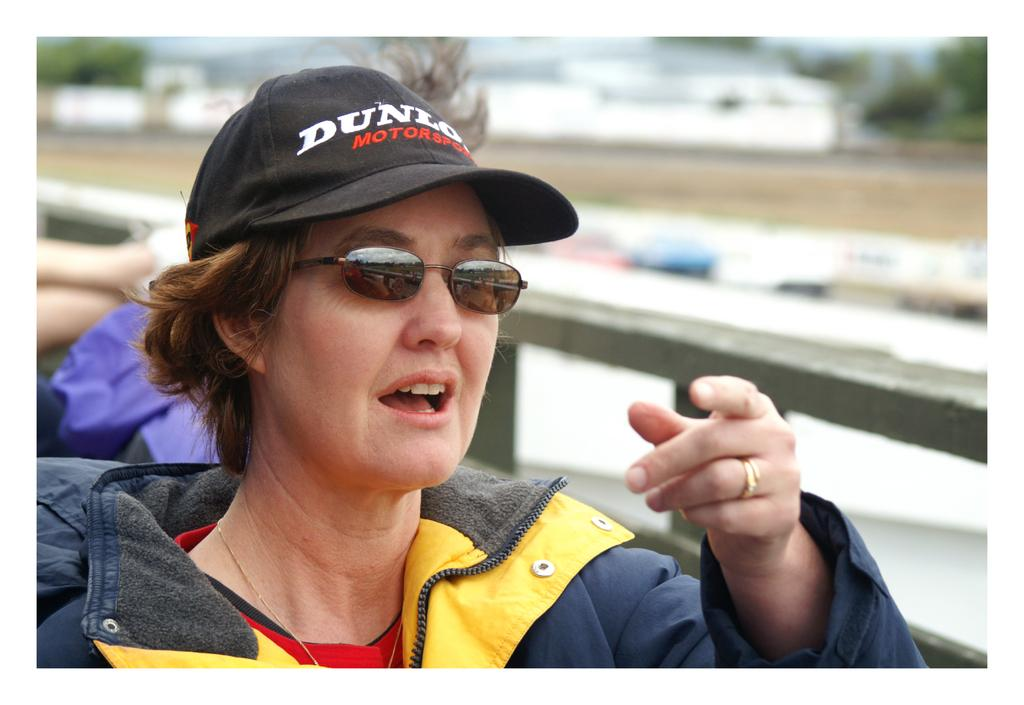Who is the main subject in the image? There is a woman in the image. What protective gear is the woman wearing? The woman is wearing goggles and a cap. Can you describe the background of the image? The background of the image is blurred. What type of story is being told by the crowd in the image? There is no crowd present in the image, so no story is being told by a crowd. 